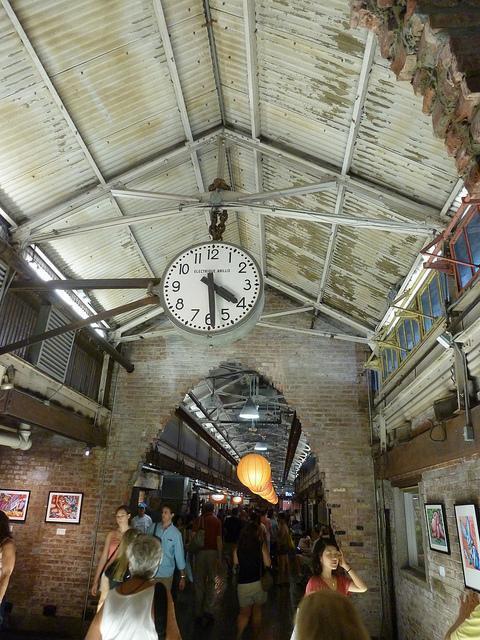What time is it approximately?
Make your selection from the four choices given to correctly answer the question.
Options: 225, 915, 430, 637. 430. 